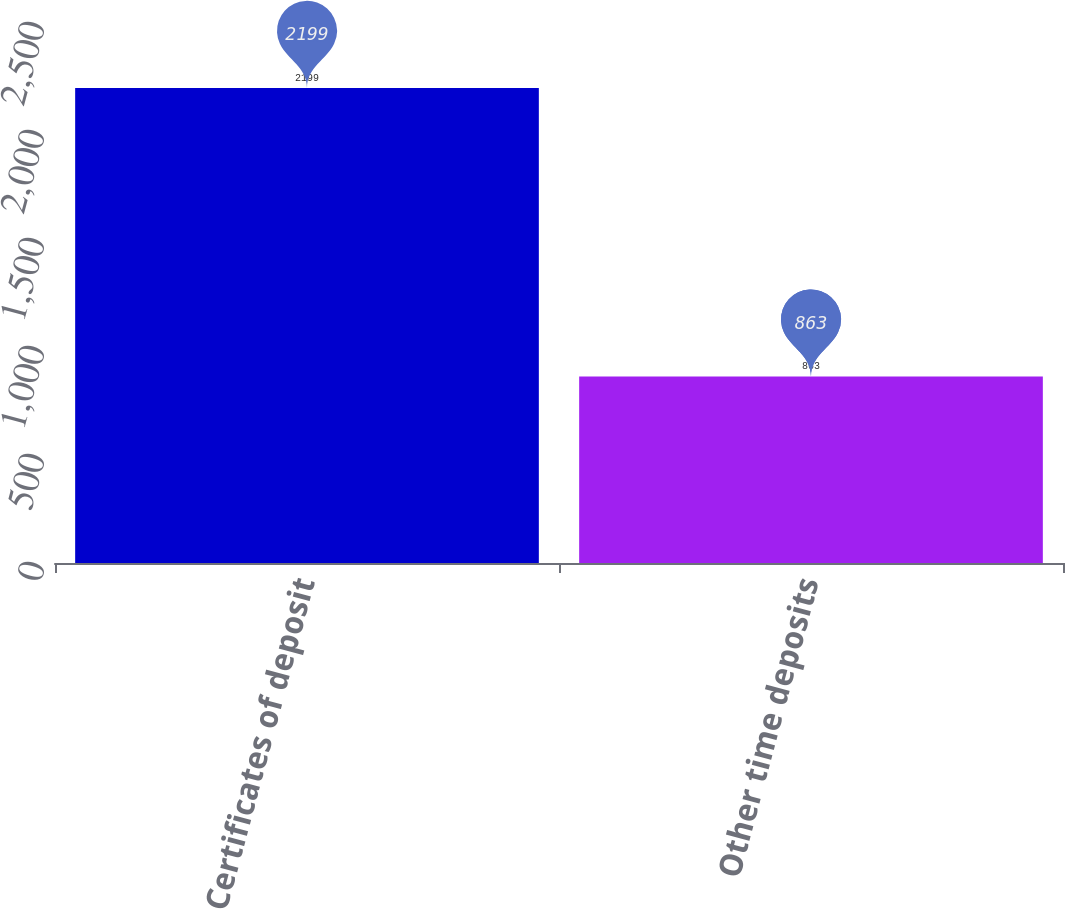<chart> <loc_0><loc_0><loc_500><loc_500><bar_chart><fcel>Certificates of deposit<fcel>Other time deposits<nl><fcel>2199<fcel>863<nl></chart> 